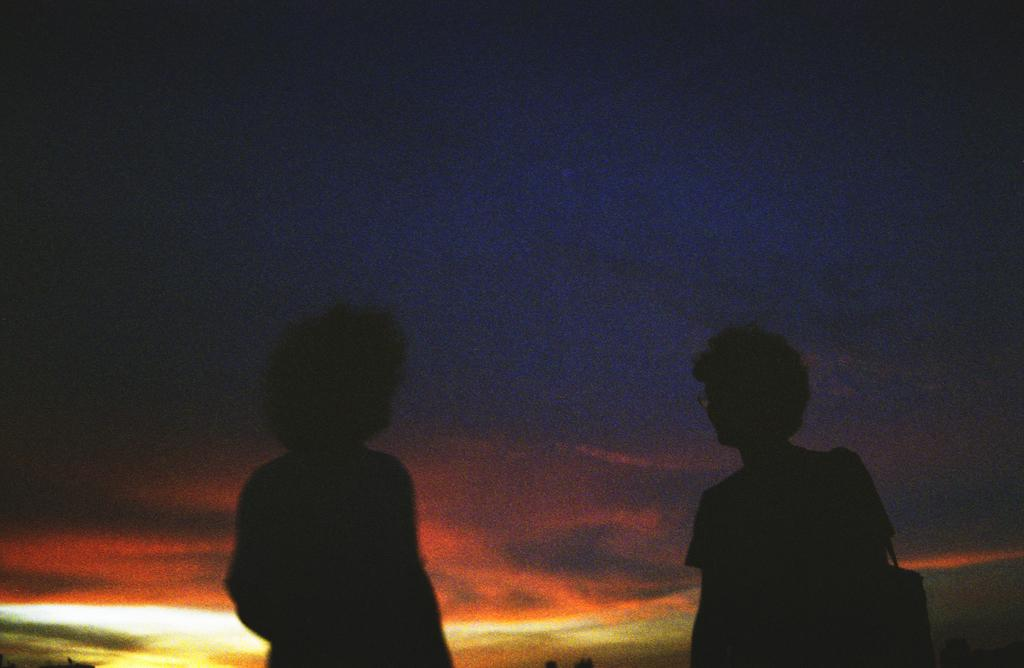How many people are in the image? There are two persons in the image. What can be seen in the background of the image? The sky is visible in the background of the image. What is the color of the sky in the image? The background sky is dark. What type of disease can be seen affecting the veins of the tomatoes in the image? There are no tomatoes or diseases present in the image; it features two persons and a dark sky in the background. 